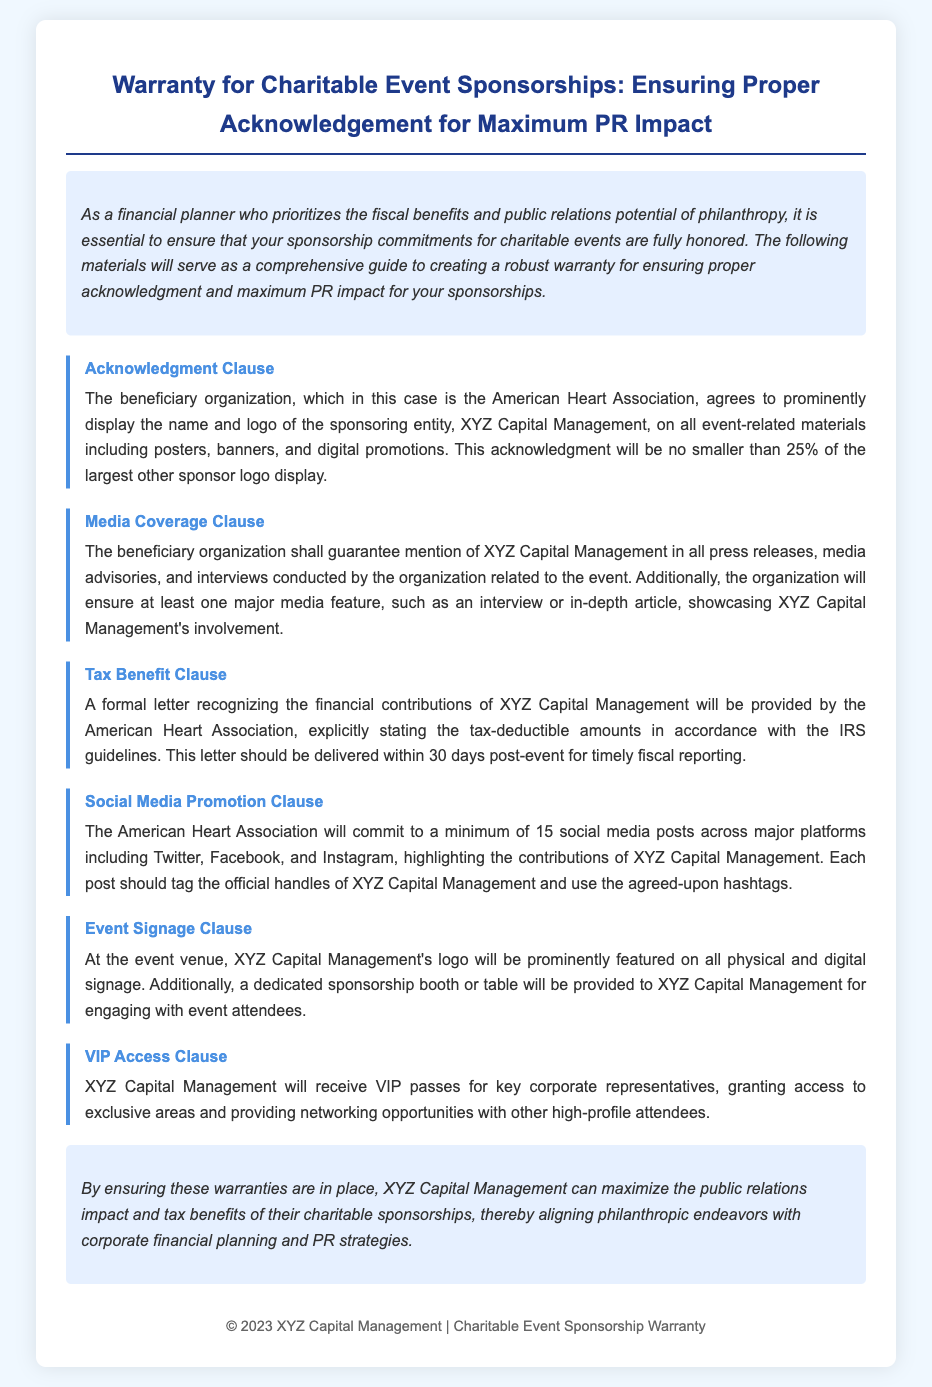What is the title of the document? The title is the main heading of the document, indicating its purpose and focus area.
Answer: Warranty for Charitable Event Sponsorships: Ensuring Proper Acknowledgement for Maximum PR Impact Who is the beneficiary organization mentioned in the document? The beneficiary organization is specified in relation to the sponsorship and acknowledgment clauses within the document.
Answer: American Heart Association What percentage must the sponsor's logo be displayed relative to other sponsors? This percentage is stated in the acknowledgment clause of the document and relates to the visibility of the sponsoring entity's branding.
Answer: 25% How many social media posts are guaranteed by the beneficiary organization? The specific number of social media posts is mentioned in the social media promotion clause.
Answer: 15 What is the purpose of the tax benefit clause? The tax benefit clause outlines the recognition provided for financial contributions in accordance with tax regulations.
Answer: To provide a formal letter recognizing tax-deductible amounts What access will XYZ Capital Management receive at the event? The type of access provided is detailed in the VIP access clause, which describes entitlements during the event.
Answer: VIP passes How long after the event should the tax letter be delivered? The timeframe for delivering the tax acknowledgment letter is stated in the tax benefit clause.
Answer: 30 days What must the acknowledgment clause ensure regarding the sponsor's name and logo? The acknowledgment clause specifies requirements for visibility and prominence of the sponsor's branding during the event.
Answer: Prominently display What is included in the media coverage clause? This clause outlines the media obligations of the beneficiary organization regarding the sponsor's mention in various formats.
Answer: Mention of XYZ Capital Management in all press releases What is one of the benefits included in the event signage clause? The event signage clause includes specific benefits related to marketing visibility at the event venue.
Answer: Dedicated sponsorship booth or table 